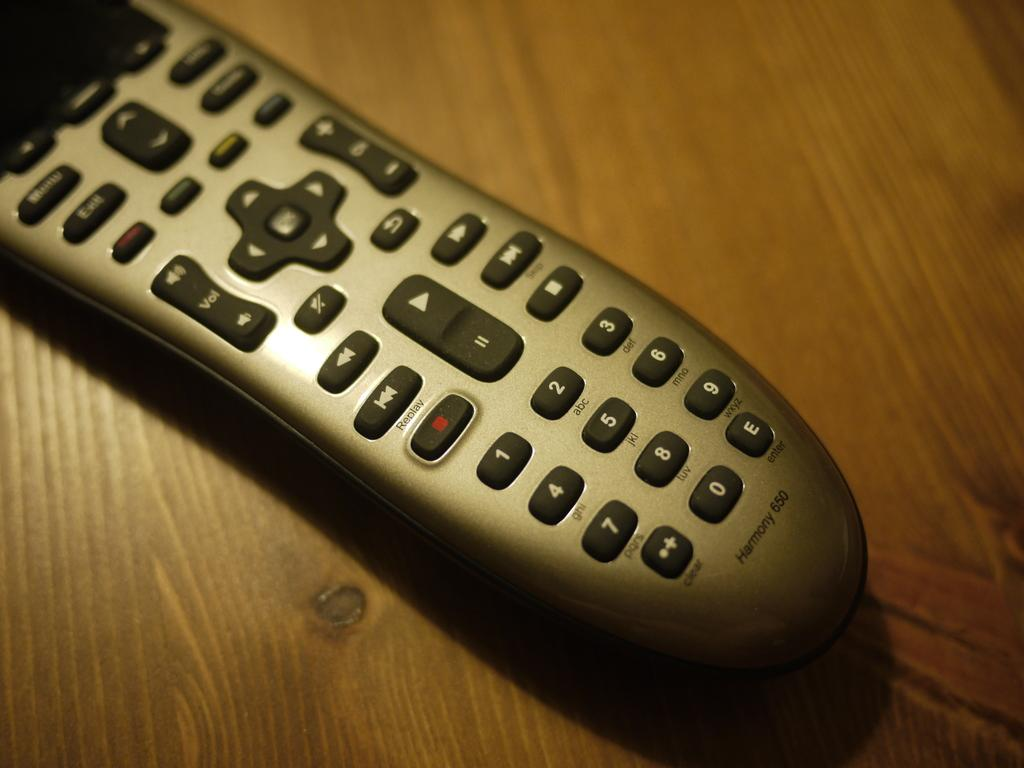<image>
Relay a brief, clear account of the picture shown. a remote control with the vol button on it 